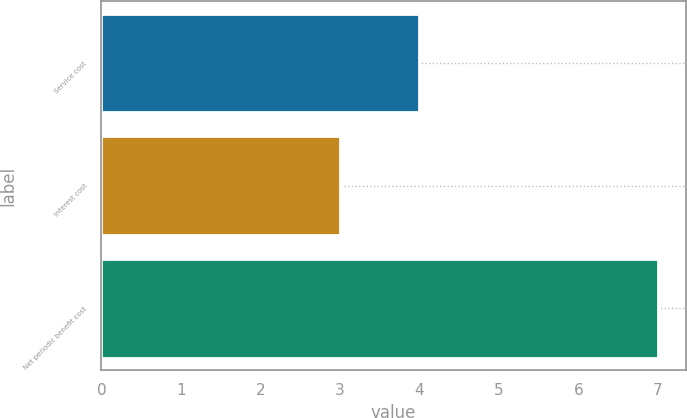Convert chart. <chart><loc_0><loc_0><loc_500><loc_500><bar_chart><fcel>Service cost<fcel>Interest cost<fcel>Net periodic benefit cost<nl><fcel>4<fcel>3<fcel>7<nl></chart> 